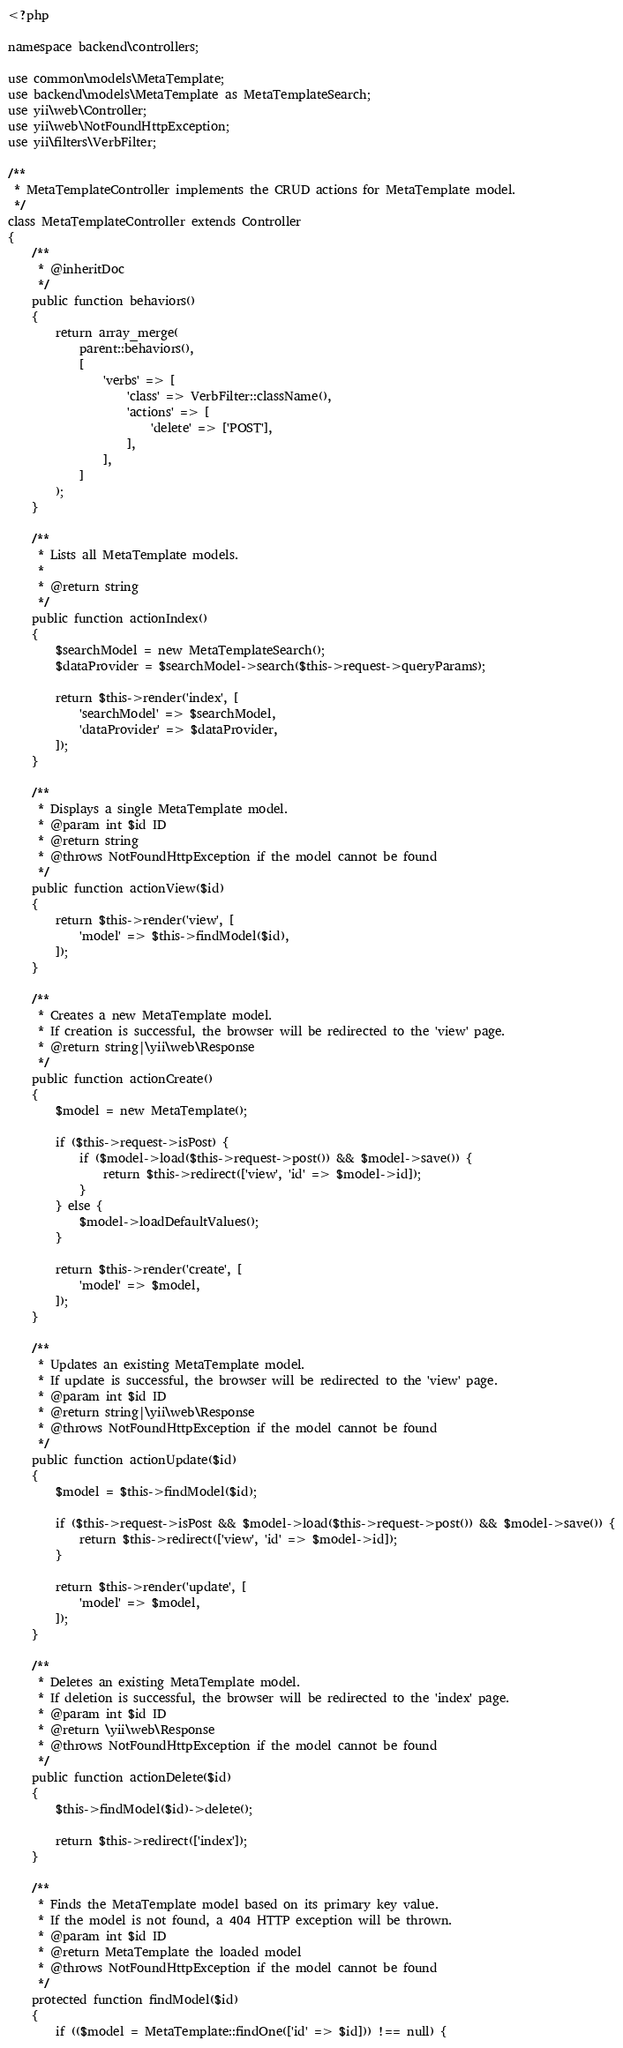<code> <loc_0><loc_0><loc_500><loc_500><_PHP_><?php

namespace backend\controllers;

use common\models\MetaTemplate;
use backend\models\MetaTemplate as MetaTemplateSearch;
use yii\web\Controller;
use yii\web\NotFoundHttpException;
use yii\filters\VerbFilter;

/**
 * MetaTemplateController implements the CRUD actions for MetaTemplate model.
 */
class MetaTemplateController extends Controller
{
    /**
     * @inheritDoc
     */
    public function behaviors()
    {
        return array_merge(
            parent::behaviors(),
            [
                'verbs' => [
                    'class' => VerbFilter::className(),
                    'actions' => [
                        'delete' => ['POST'],
                    ],
                ],
            ]
        );
    }

    /**
     * Lists all MetaTemplate models.
     *
     * @return string
     */
    public function actionIndex()
    {
        $searchModel = new MetaTemplateSearch();
        $dataProvider = $searchModel->search($this->request->queryParams);

        return $this->render('index', [
            'searchModel' => $searchModel,
            'dataProvider' => $dataProvider,
        ]);
    }

    /**
     * Displays a single MetaTemplate model.
     * @param int $id ID
     * @return string
     * @throws NotFoundHttpException if the model cannot be found
     */
    public function actionView($id)
    {
        return $this->render('view', [
            'model' => $this->findModel($id),
        ]);
    }

    /**
     * Creates a new MetaTemplate model.
     * If creation is successful, the browser will be redirected to the 'view' page.
     * @return string|\yii\web\Response
     */
    public function actionCreate()
    {
        $model = new MetaTemplate();

        if ($this->request->isPost) {
            if ($model->load($this->request->post()) && $model->save()) {
                return $this->redirect(['view', 'id' => $model->id]);
            }
        } else {
            $model->loadDefaultValues();
        }

        return $this->render('create', [
            'model' => $model,
        ]);
    }

    /**
     * Updates an existing MetaTemplate model.
     * If update is successful, the browser will be redirected to the 'view' page.
     * @param int $id ID
     * @return string|\yii\web\Response
     * @throws NotFoundHttpException if the model cannot be found
     */
    public function actionUpdate($id)
    {
        $model = $this->findModel($id);

        if ($this->request->isPost && $model->load($this->request->post()) && $model->save()) {
            return $this->redirect(['view', 'id' => $model->id]);
        }

        return $this->render('update', [
            'model' => $model,
        ]);
    }

    /**
     * Deletes an existing MetaTemplate model.
     * If deletion is successful, the browser will be redirected to the 'index' page.
     * @param int $id ID
     * @return \yii\web\Response
     * @throws NotFoundHttpException if the model cannot be found
     */
    public function actionDelete($id)
    {
        $this->findModel($id)->delete();

        return $this->redirect(['index']);
    }

    /**
     * Finds the MetaTemplate model based on its primary key value.
     * If the model is not found, a 404 HTTP exception will be thrown.
     * @param int $id ID
     * @return MetaTemplate the loaded model
     * @throws NotFoundHttpException if the model cannot be found
     */
    protected function findModel($id)
    {
        if (($model = MetaTemplate::findOne(['id' => $id])) !== null) {</code> 